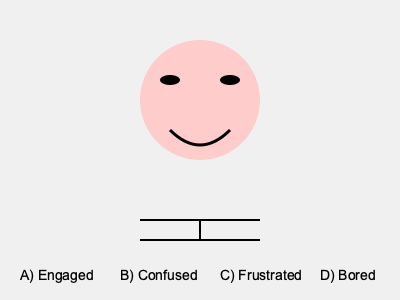Based on the facial expression and body language depicted in the image, which emotion is the speech therapy client most likely experiencing during the session? To interpret the body language and facial expression in the image, let's analyze the key features:

1. Eyes: The eyes are wide open, indicating alertness and attention.
2. Eyebrows: Not visible, but the overall eye area doesn't show signs of furrowing or raising, which would indicate confusion or surprise.
3. Mouth: The corners of the mouth are turned upward in a smile, suggesting a positive emotion.
4. Body posture: The image shows a straight line representing an upright posture, implying attentiveness and engagement.

Given these observations:
- The wide eyes and upright posture suggest the client is alert and attentive.
- The smile indicates a positive emotional state.
- There are no signs of furrowed brows, crossed arms, or slumped posture that might indicate confusion, frustration, or boredom.

Therefore, the most likely emotion the speech therapy client is experiencing is engagement. They appear to be actively participating in the session with a positive attitude.
Answer: Engaged 